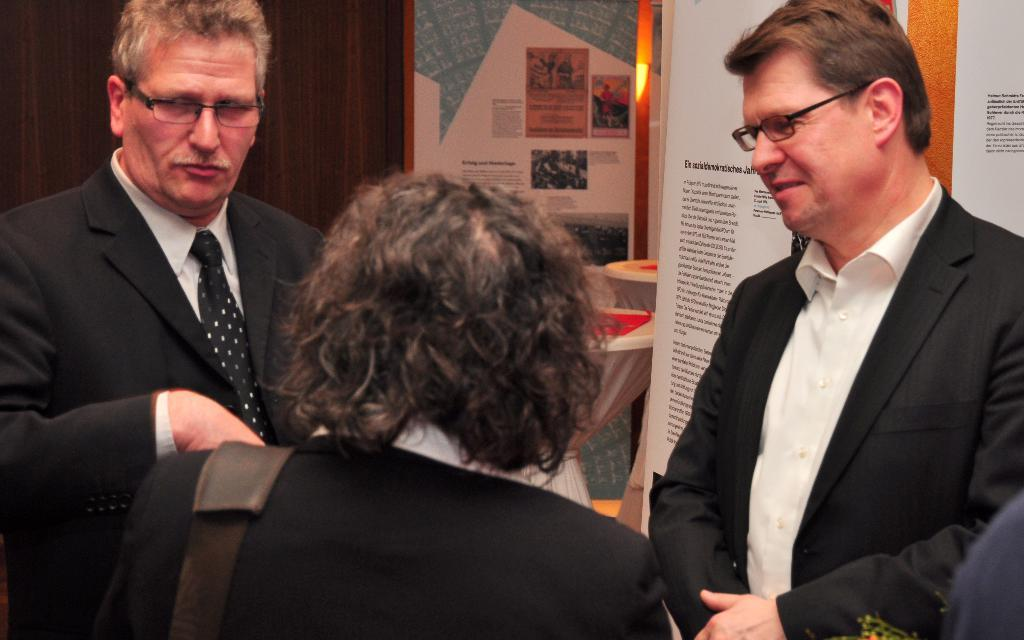How many people are in the image? There are three persons standing in the image. What can be seen in the background of the image? There is a wall, a mirror, tables, and boards in the background of the image. What type of location might the image have been taken in? The image may have been taken in a hall. What type of pest can be seen crawling on the tables in the image? There are no pests visible in the image; only the wall, mirror, tables, and boards can be seen in the background. 